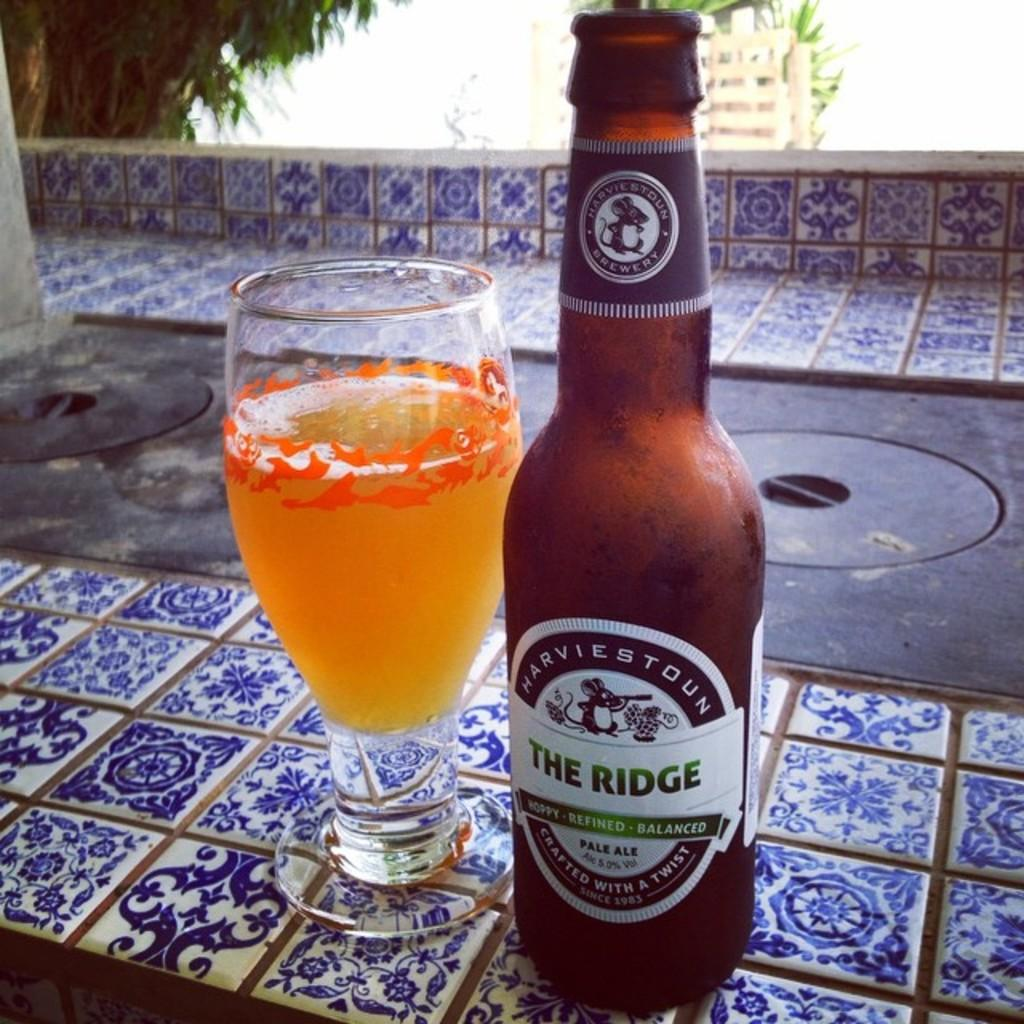What type of container is visible in the image? There is a glass bottle in the image. What other glass object can be seen in the image? There is a glass in the image. What can be seen in the background of the image? There is a tree and a building in the background of the image. What type of hair can be seen on the glass bottle in the image? There is no hair present on the glass bottle in the image. What type of pies are being served on the glass in the image? There is no mention of pies in the image; the glass bottle and glass are the main focus. 